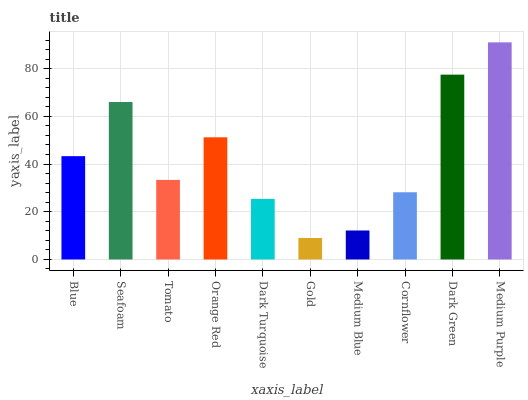Is Gold the minimum?
Answer yes or no. Yes. Is Medium Purple the maximum?
Answer yes or no. Yes. Is Seafoam the minimum?
Answer yes or no. No. Is Seafoam the maximum?
Answer yes or no. No. Is Seafoam greater than Blue?
Answer yes or no. Yes. Is Blue less than Seafoam?
Answer yes or no. Yes. Is Blue greater than Seafoam?
Answer yes or no. No. Is Seafoam less than Blue?
Answer yes or no. No. Is Blue the high median?
Answer yes or no. Yes. Is Tomato the low median?
Answer yes or no. Yes. Is Orange Red the high median?
Answer yes or no. No. Is Cornflower the low median?
Answer yes or no. No. 